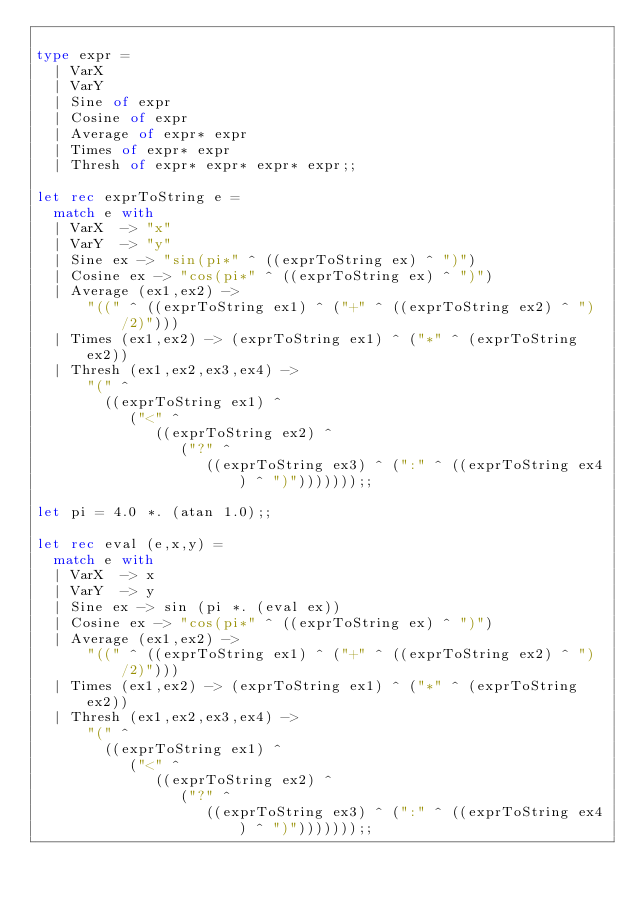Convert code to text. <code><loc_0><loc_0><loc_500><loc_500><_OCaml_>
type expr =
  | VarX
  | VarY
  | Sine of expr
  | Cosine of expr
  | Average of expr* expr
  | Times of expr* expr
  | Thresh of expr* expr* expr* expr;;

let rec exprToString e =
  match e with
  | VarX  -> "x"
  | VarY  -> "y"
  | Sine ex -> "sin(pi*" ^ ((exprToString ex) ^ ")")
  | Cosine ex -> "cos(pi*" ^ ((exprToString ex) ^ ")")
  | Average (ex1,ex2) ->
      "((" ^ ((exprToString ex1) ^ ("+" ^ ((exprToString ex2) ^ ")/2)")))
  | Times (ex1,ex2) -> (exprToString ex1) ^ ("*" ^ (exprToString ex2))
  | Thresh (ex1,ex2,ex3,ex4) ->
      "(" ^
        ((exprToString ex1) ^
           ("<" ^
              ((exprToString ex2) ^
                 ("?" ^
                    ((exprToString ex3) ^ (":" ^ ((exprToString ex4) ^ ")")))))));;

let pi = 4.0 *. (atan 1.0);;

let rec eval (e,x,y) =
  match e with
  | VarX  -> x
  | VarY  -> y
  | Sine ex -> sin (pi *. (eval ex))
  | Cosine ex -> "cos(pi*" ^ ((exprToString ex) ^ ")")
  | Average (ex1,ex2) ->
      "((" ^ ((exprToString ex1) ^ ("+" ^ ((exprToString ex2) ^ ")/2)")))
  | Times (ex1,ex2) -> (exprToString ex1) ^ ("*" ^ (exprToString ex2))
  | Thresh (ex1,ex2,ex3,ex4) ->
      "(" ^
        ((exprToString ex1) ^
           ("<" ^
              ((exprToString ex2) ^
                 ("?" ^
                    ((exprToString ex3) ^ (":" ^ ((exprToString ex4) ^ ")")))))));;
</code> 